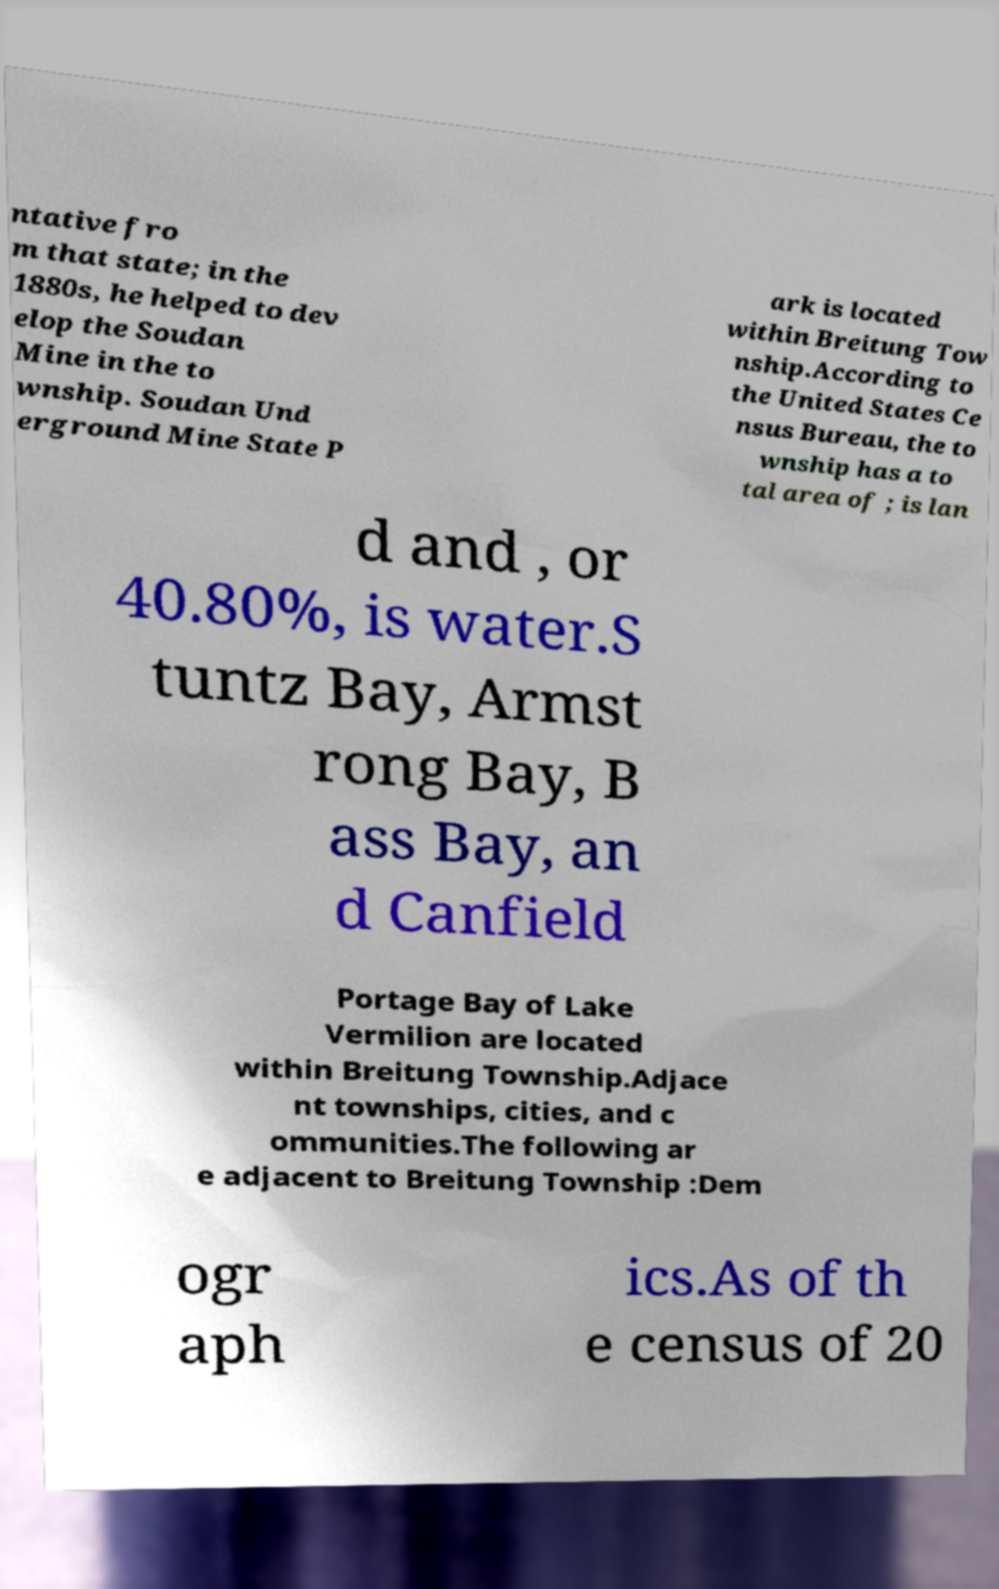For documentation purposes, I need the text within this image transcribed. Could you provide that? ntative fro m that state; in the 1880s, he helped to dev elop the Soudan Mine in the to wnship. Soudan Und erground Mine State P ark is located within Breitung Tow nship.According to the United States Ce nsus Bureau, the to wnship has a to tal area of ; is lan d and , or 40.80%, is water.S tuntz Bay, Armst rong Bay, B ass Bay, an d Canfield Portage Bay of Lake Vermilion are located within Breitung Township.Adjace nt townships, cities, and c ommunities.The following ar e adjacent to Breitung Township :Dem ogr aph ics.As of th e census of 20 